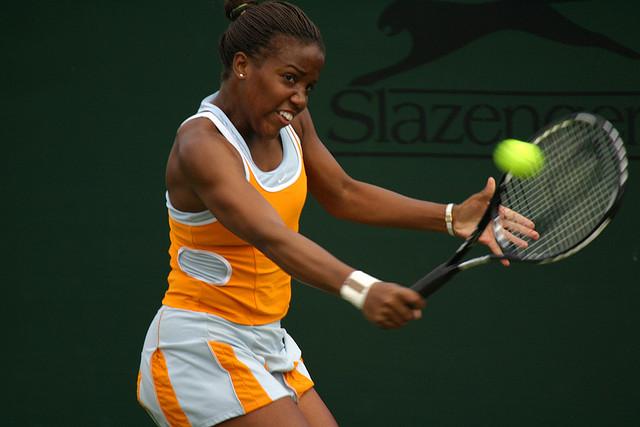What colors are women's clothes?
Be succinct. Orange and white. What letter or number is on the man's racket?
Keep it brief. 9. What is on her left wrist?
Concise answer only. Watch. Why does she look like she is taking a poo?
Concise answer only. She is straining. 